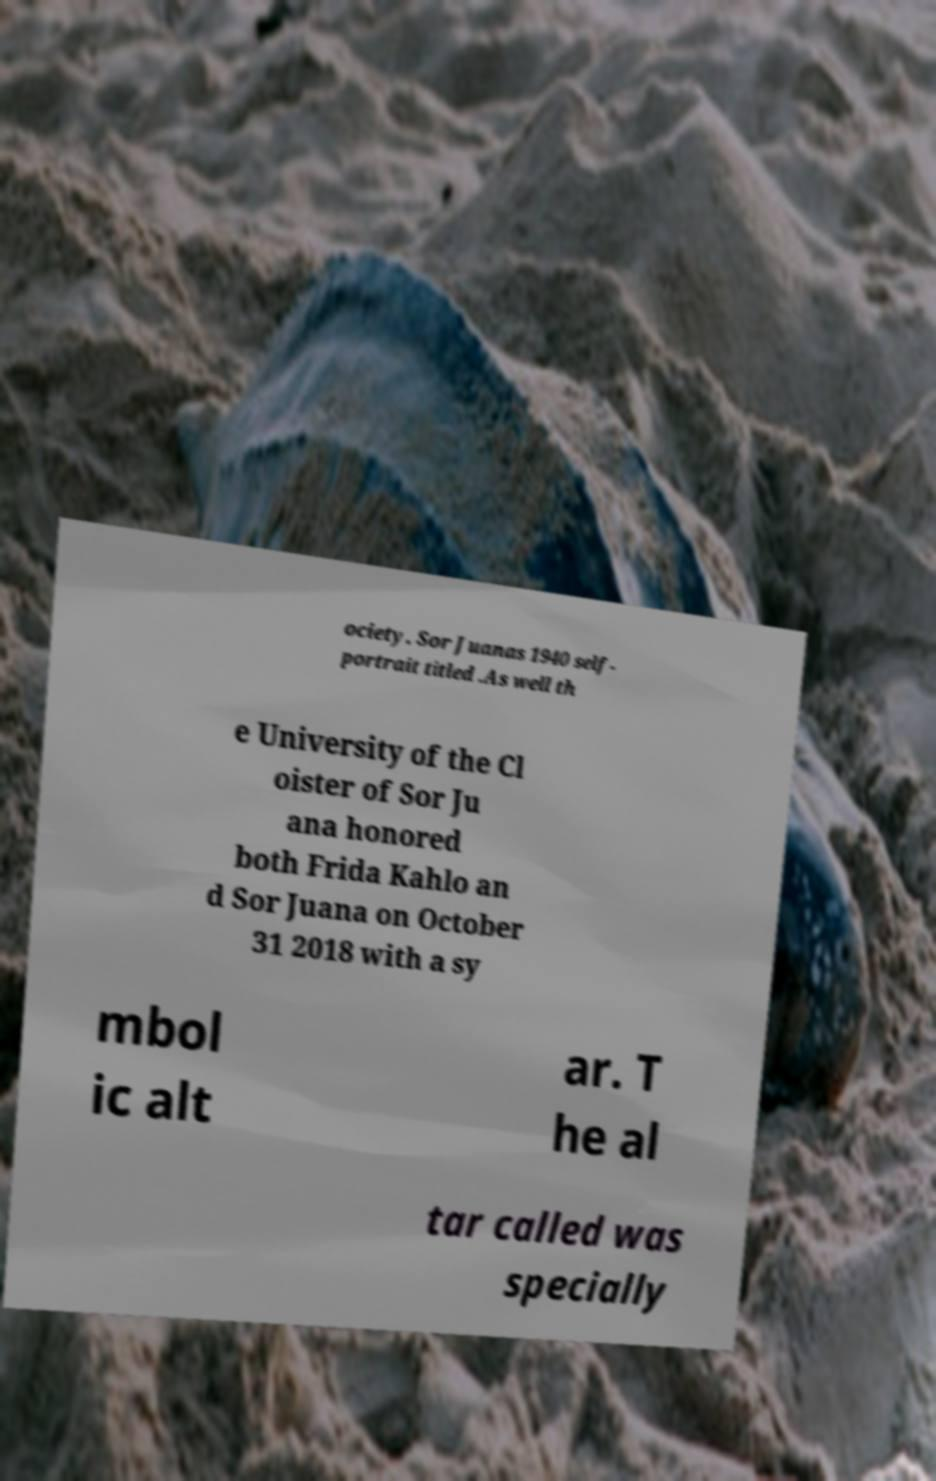I need the written content from this picture converted into text. Can you do that? ociety. Sor Juanas 1940 self- portrait titled .As well th e University of the Cl oister of Sor Ju ana honored both Frida Kahlo an d Sor Juana on October 31 2018 with a sy mbol ic alt ar. T he al tar called was specially 